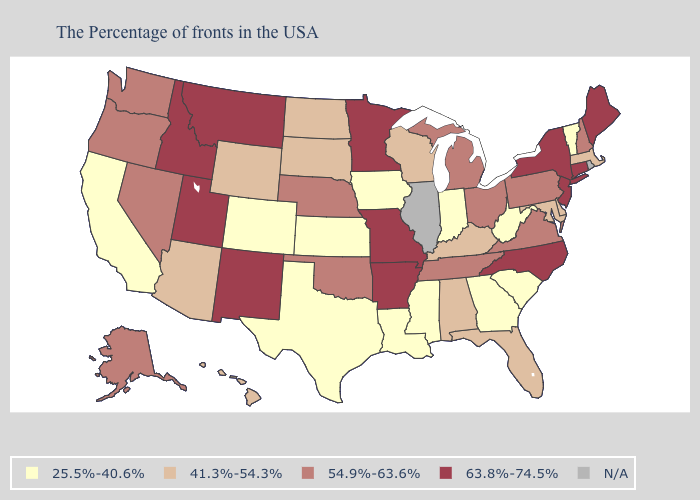What is the highest value in states that border North Dakota?
Answer briefly. 63.8%-74.5%. Does Louisiana have the lowest value in the South?
Give a very brief answer. Yes. Does Colorado have the lowest value in the West?
Short answer required. Yes. Is the legend a continuous bar?
Short answer required. No. Among the states that border Arizona , which have the highest value?
Keep it brief. New Mexico, Utah. What is the highest value in states that border Maryland?
Be succinct. 54.9%-63.6%. What is the value of Missouri?
Give a very brief answer. 63.8%-74.5%. What is the value of West Virginia?
Concise answer only. 25.5%-40.6%. Does Wyoming have the highest value in the USA?
Keep it brief. No. Name the states that have a value in the range 63.8%-74.5%?
Answer briefly. Maine, Connecticut, New York, New Jersey, North Carolina, Missouri, Arkansas, Minnesota, New Mexico, Utah, Montana, Idaho. Name the states that have a value in the range N/A?
Be succinct. Rhode Island, Illinois. Among the states that border Ohio , does Pennsylvania have the highest value?
Short answer required. Yes. Name the states that have a value in the range 41.3%-54.3%?
Answer briefly. Massachusetts, Delaware, Maryland, Florida, Kentucky, Alabama, Wisconsin, South Dakota, North Dakota, Wyoming, Arizona, Hawaii. Name the states that have a value in the range 63.8%-74.5%?
Be succinct. Maine, Connecticut, New York, New Jersey, North Carolina, Missouri, Arkansas, Minnesota, New Mexico, Utah, Montana, Idaho. Name the states that have a value in the range 25.5%-40.6%?
Concise answer only. Vermont, South Carolina, West Virginia, Georgia, Indiana, Mississippi, Louisiana, Iowa, Kansas, Texas, Colorado, California. 